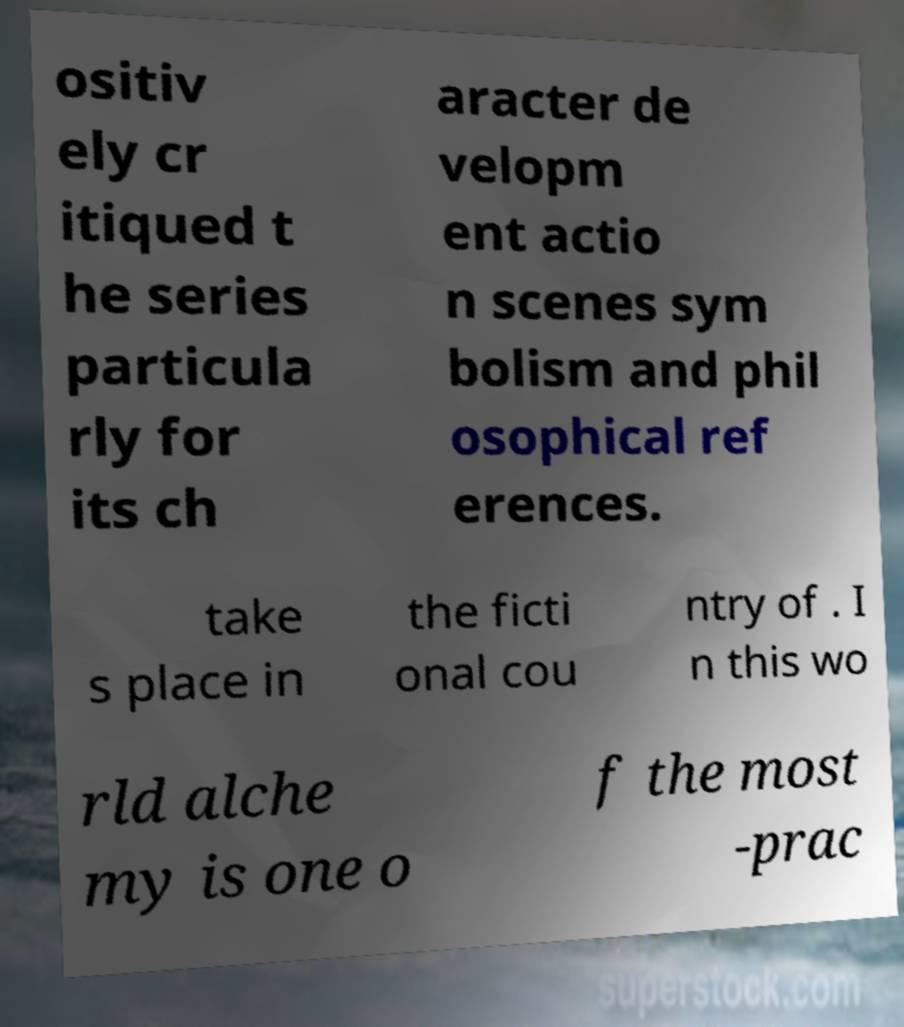Could you assist in decoding the text presented in this image and type it out clearly? ositiv ely cr itiqued t he series particula rly for its ch aracter de velopm ent actio n scenes sym bolism and phil osophical ref erences. take s place in the ficti onal cou ntry of . I n this wo rld alche my is one o f the most -prac 